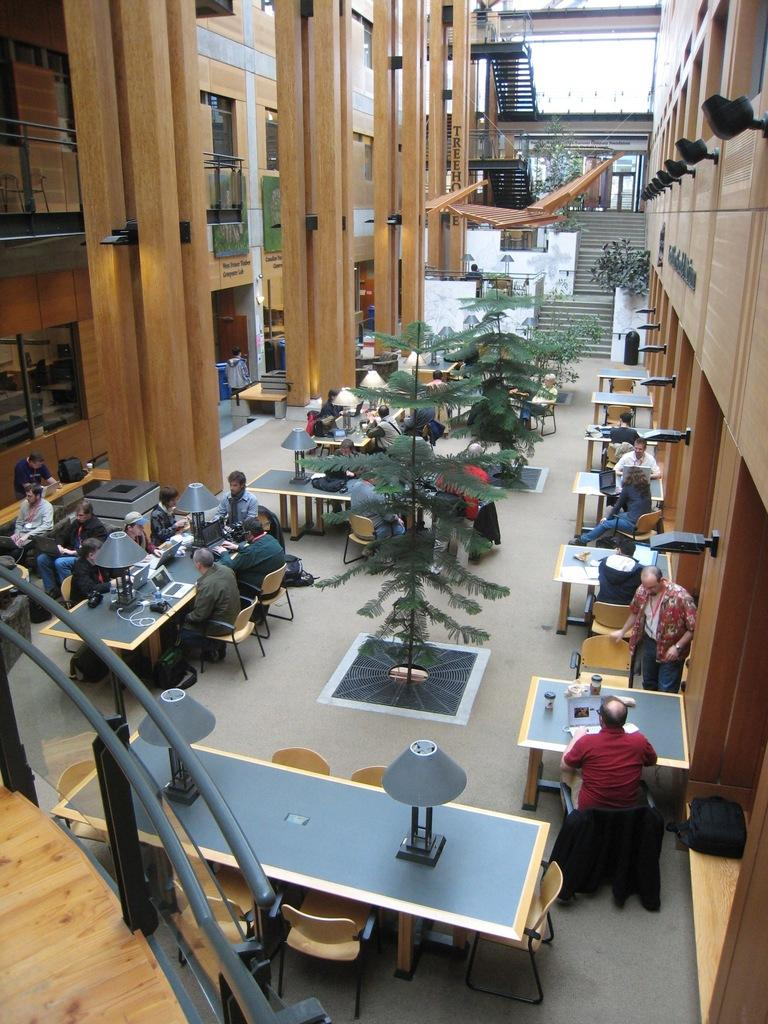What are the people in the image doing? The persons in the image are sitting on chairs. What objects are present in the image that the people might be using? There are tables in the image that the people might be using. What type of vegetation can be seen in the image? There are plants in the image. What type of structure is visible in the background? There is a building in the image. What type of fuel is required to operate the system in the image? There is no system or fuel present in the image; it features people sitting on chairs, tables, plants, and a building. 